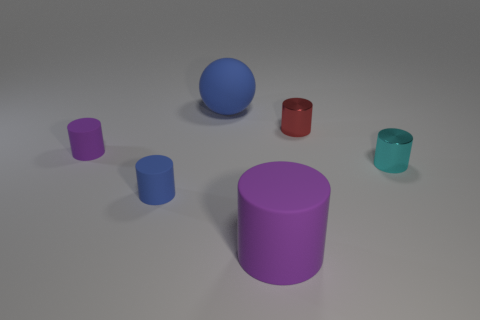Is there a small purple rubber object that has the same shape as the tiny red metal thing?
Provide a short and direct response. Yes. There is a small object that is the same color as the big rubber sphere; what material is it?
Provide a succinct answer. Rubber. The purple matte thing behind the cyan metal cylinder has what shape?
Your answer should be compact. Cylinder. How many large brown shiny cylinders are there?
Keep it short and to the point. 0. What color is the big object that is the same material as the blue sphere?
Ensure brevity in your answer.  Purple. How many small objects are either red metallic things or matte things?
Your answer should be very brief. 3. There is a cyan shiny thing; what number of purple rubber things are on the right side of it?
Offer a terse response. 0. There is a big rubber object that is the same shape as the tiny purple matte thing; what color is it?
Provide a succinct answer. Purple. How many shiny objects are cylinders or blue cylinders?
Ensure brevity in your answer.  2. There is a red metallic thing in front of the big object that is behind the tiny purple matte object; are there any tiny purple matte things left of it?
Keep it short and to the point. Yes. 